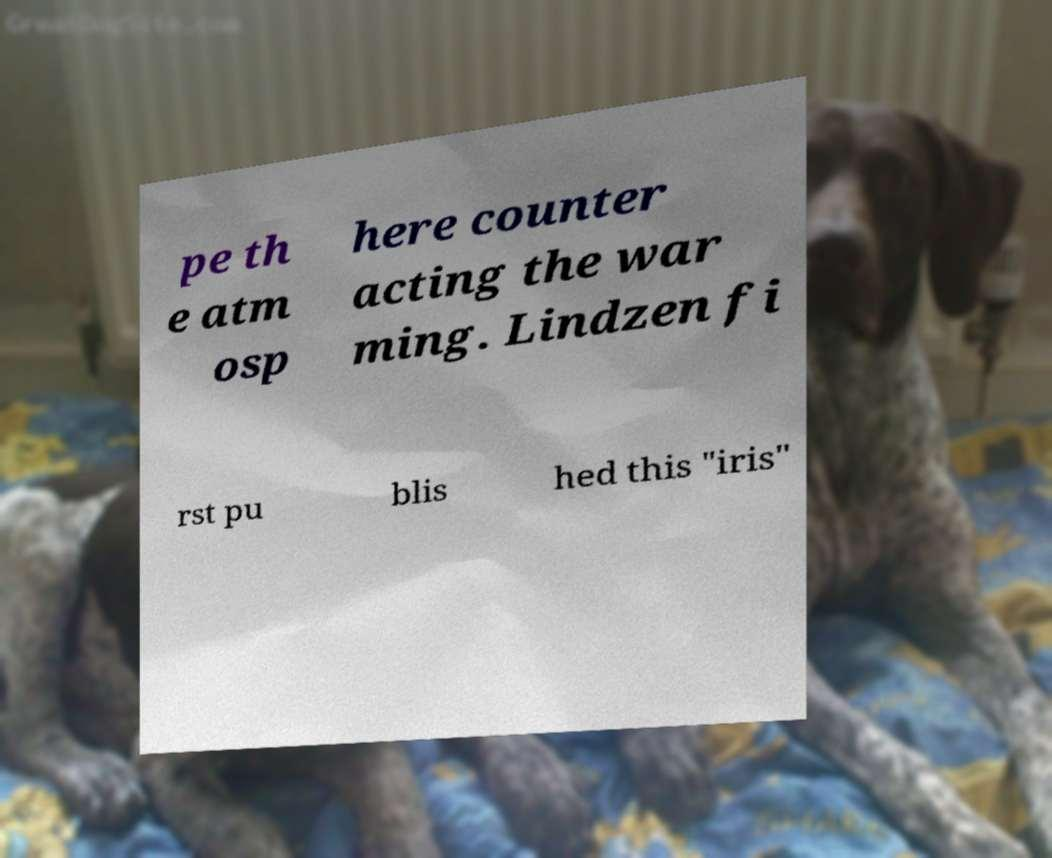What messages or text are displayed in this image? I need them in a readable, typed format. pe th e atm osp here counter acting the war ming. Lindzen fi rst pu blis hed this "iris" 